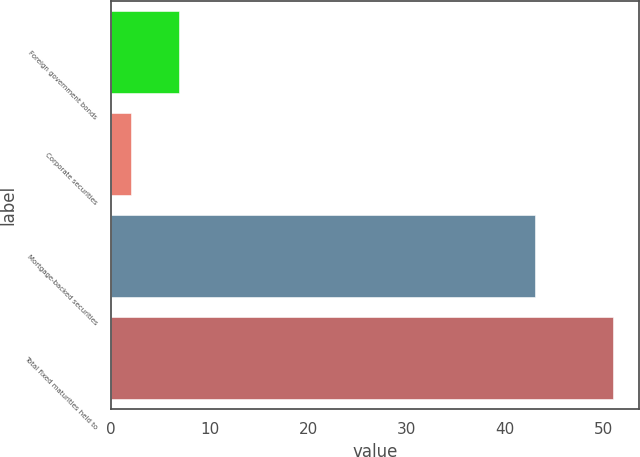Convert chart. <chart><loc_0><loc_0><loc_500><loc_500><bar_chart><fcel>Foreign government bonds<fcel>Corporate securities<fcel>Mortgage-backed securities<fcel>Total fixed maturities held to<nl><fcel>6.9<fcel>2<fcel>43<fcel>51<nl></chart> 